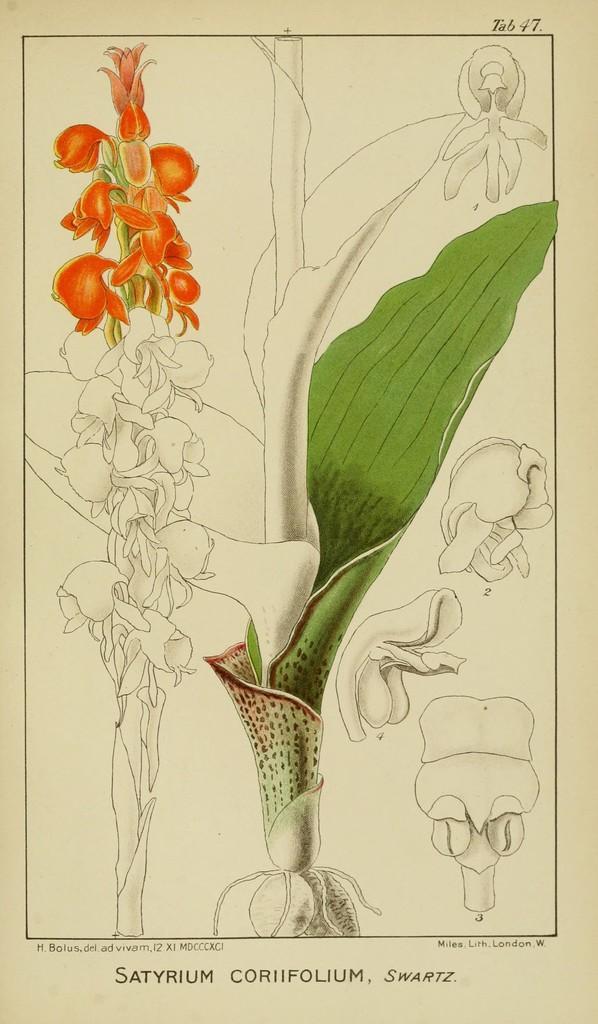Describe this image in one or two sentences. In this image we can see a picture. In the picture there are the images of plants. 